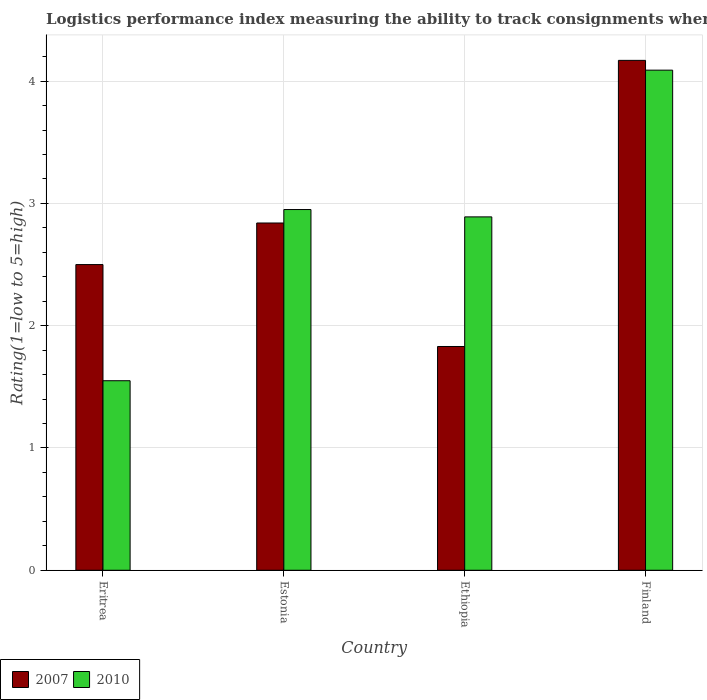How many different coloured bars are there?
Offer a very short reply. 2. How many groups of bars are there?
Your response must be concise. 4. Are the number of bars per tick equal to the number of legend labels?
Your response must be concise. Yes. Are the number of bars on each tick of the X-axis equal?
Keep it short and to the point. Yes. In how many cases, is the number of bars for a given country not equal to the number of legend labels?
Ensure brevity in your answer.  0. Across all countries, what is the maximum Logistic performance index in 2010?
Keep it short and to the point. 4.09. Across all countries, what is the minimum Logistic performance index in 2007?
Give a very brief answer. 1.83. In which country was the Logistic performance index in 2010 maximum?
Offer a terse response. Finland. In which country was the Logistic performance index in 2007 minimum?
Make the answer very short. Ethiopia. What is the total Logistic performance index in 2010 in the graph?
Your answer should be compact. 11.48. What is the difference between the Logistic performance index in 2007 in Eritrea and that in Estonia?
Offer a terse response. -0.34. What is the difference between the Logistic performance index in 2010 in Finland and the Logistic performance index in 2007 in Ethiopia?
Your answer should be very brief. 2.26. What is the average Logistic performance index in 2010 per country?
Make the answer very short. 2.87. What is the difference between the Logistic performance index of/in 2007 and Logistic performance index of/in 2010 in Ethiopia?
Your answer should be very brief. -1.06. What is the ratio of the Logistic performance index in 2007 in Eritrea to that in Finland?
Give a very brief answer. 0.6. Is the Logistic performance index in 2010 in Eritrea less than that in Ethiopia?
Your answer should be compact. Yes. What is the difference between the highest and the second highest Logistic performance index in 2010?
Your response must be concise. 0.06. What is the difference between the highest and the lowest Logistic performance index in 2010?
Offer a terse response. 2.54. Is the sum of the Logistic performance index in 2007 in Eritrea and Estonia greater than the maximum Logistic performance index in 2010 across all countries?
Your response must be concise. Yes. What does the 2nd bar from the right in Estonia represents?
Your answer should be very brief. 2007. How many bars are there?
Your response must be concise. 8. Where does the legend appear in the graph?
Your response must be concise. Bottom left. How are the legend labels stacked?
Give a very brief answer. Horizontal. What is the title of the graph?
Offer a terse response. Logistics performance index measuring the ability to track consignments when shipping to a market. Does "2000" appear as one of the legend labels in the graph?
Ensure brevity in your answer.  No. What is the label or title of the Y-axis?
Keep it short and to the point. Rating(1=low to 5=high). What is the Rating(1=low to 5=high) of 2007 in Eritrea?
Keep it short and to the point. 2.5. What is the Rating(1=low to 5=high) of 2010 in Eritrea?
Provide a succinct answer. 1.55. What is the Rating(1=low to 5=high) of 2007 in Estonia?
Ensure brevity in your answer.  2.84. What is the Rating(1=low to 5=high) of 2010 in Estonia?
Ensure brevity in your answer.  2.95. What is the Rating(1=low to 5=high) of 2007 in Ethiopia?
Your answer should be very brief. 1.83. What is the Rating(1=low to 5=high) of 2010 in Ethiopia?
Offer a very short reply. 2.89. What is the Rating(1=low to 5=high) of 2007 in Finland?
Your response must be concise. 4.17. What is the Rating(1=low to 5=high) in 2010 in Finland?
Keep it short and to the point. 4.09. Across all countries, what is the maximum Rating(1=low to 5=high) in 2007?
Offer a very short reply. 4.17. Across all countries, what is the maximum Rating(1=low to 5=high) in 2010?
Provide a short and direct response. 4.09. Across all countries, what is the minimum Rating(1=low to 5=high) of 2007?
Provide a short and direct response. 1.83. Across all countries, what is the minimum Rating(1=low to 5=high) in 2010?
Offer a terse response. 1.55. What is the total Rating(1=low to 5=high) of 2007 in the graph?
Your response must be concise. 11.34. What is the total Rating(1=low to 5=high) of 2010 in the graph?
Give a very brief answer. 11.48. What is the difference between the Rating(1=low to 5=high) of 2007 in Eritrea and that in Estonia?
Your answer should be very brief. -0.34. What is the difference between the Rating(1=low to 5=high) in 2007 in Eritrea and that in Ethiopia?
Your response must be concise. 0.67. What is the difference between the Rating(1=low to 5=high) of 2010 in Eritrea and that in Ethiopia?
Keep it short and to the point. -1.34. What is the difference between the Rating(1=low to 5=high) of 2007 in Eritrea and that in Finland?
Offer a very short reply. -1.67. What is the difference between the Rating(1=low to 5=high) of 2010 in Eritrea and that in Finland?
Your answer should be compact. -2.54. What is the difference between the Rating(1=low to 5=high) in 2007 in Estonia and that in Finland?
Ensure brevity in your answer.  -1.33. What is the difference between the Rating(1=low to 5=high) of 2010 in Estonia and that in Finland?
Offer a terse response. -1.14. What is the difference between the Rating(1=low to 5=high) of 2007 in Ethiopia and that in Finland?
Make the answer very short. -2.34. What is the difference between the Rating(1=low to 5=high) of 2010 in Ethiopia and that in Finland?
Provide a short and direct response. -1.2. What is the difference between the Rating(1=low to 5=high) in 2007 in Eritrea and the Rating(1=low to 5=high) in 2010 in Estonia?
Offer a very short reply. -0.45. What is the difference between the Rating(1=low to 5=high) of 2007 in Eritrea and the Rating(1=low to 5=high) of 2010 in Ethiopia?
Offer a very short reply. -0.39. What is the difference between the Rating(1=low to 5=high) in 2007 in Eritrea and the Rating(1=low to 5=high) in 2010 in Finland?
Your response must be concise. -1.59. What is the difference between the Rating(1=low to 5=high) in 2007 in Estonia and the Rating(1=low to 5=high) in 2010 in Ethiopia?
Your response must be concise. -0.05. What is the difference between the Rating(1=low to 5=high) in 2007 in Estonia and the Rating(1=low to 5=high) in 2010 in Finland?
Keep it short and to the point. -1.25. What is the difference between the Rating(1=low to 5=high) in 2007 in Ethiopia and the Rating(1=low to 5=high) in 2010 in Finland?
Your response must be concise. -2.26. What is the average Rating(1=low to 5=high) in 2007 per country?
Make the answer very short. 2.83. What is the average Rating(1=low to 5=high) in 2010 per country?
Offer a terse response. 2.87. What is the difference between the Rating(1=low to 5=high) in 2007 and Rating(1=low to 5=high) in 2010 in Estonia?
Your answer should be compact. -0.11. What is the difference between the Rating(1=low to 5=high) of 2007 and Rating(1=low to 5=high) of 2010 in Ethiopia?
Offer a very short reply. -1.06. What is the difference between the Rating(1=low to 5=high) of 2007 and Rating(1=low to 5=high) of 2010 in Finland?
Your answer should be compact. 0.08. What is the ratio of the Rating(1=low to 5=high) in 2007 in Eritrea to that in Estonia?
Ensure brevity in your answer.  0.88. What is the ratio of the Rating(1=low to 5=high) in 2010 in Eritrea to that in Estonia?
Your answer should be compact. 0.53. What is the ratio of the Rating(1=low to 5=high) of 2007 in Eritrea to that in Ethiopia?
Your answer should be very brief. 1.37. What is the ratio of the Rating(1=low to 5=high) of 2010 in Eritrea to that in Ethiopia?
Ensure brevity in your answer.  0.54. What is the ratio of the Rating(1=low to 5=high) of 2007 in Eritrea to that in Finland?
Your answer should be compact. 0.6. What is the ratio of the Rating(1=low to 5=high) in 2010 in Eritrea to that in Finland?
Make the answer very short. 0.38. What is the ratio of the Rating(1=low to 5=high) of 2007 in Estonia to that in Ethiopia?
Offer a very short reply. 1.55. What is the ratio of the Rating(1=low to 5=high) in 2010 in Estonia to that in Ethiopia?
Keep it short and to the point. 1.02. What is the ratio of the Rating(1=low to 5=high) of 2007 in Estonia to that in Finland?
Make the answer very short. 0.68. What is the ratio of the Rating(1=low to 5=high) of 2010 in Estonia to that in Finland?
Provide a short and direct response. 0.72. What is the ratio of the Rating(1=low to 5=high) in 2007 in Ethiopia to that in Finland?
Ensure brevity in your answer.  0.44. What is the ratio of the Rating(1=low to 5=high) of 2010 in Ethiopia to that in Finland?
Make the answer very short. 0.71. What is the difference between the highest and the second highest Rating(1=low to 5=high) of 2007?
Keep it short and to the point. 1.33. What is the difference between the highest and the second highest Rating(1=low to 5=high) of 2010?
Your response must be concise. 1.14. What is the difference between the highest and the lowest Rating(1=low to 5=high) in 2007?
Make the answer very short. 2.34. What is the difference between the highest and the lowest Rating(1=low to 5=high) of 2010?
Give a very brief answer. 2.54. 